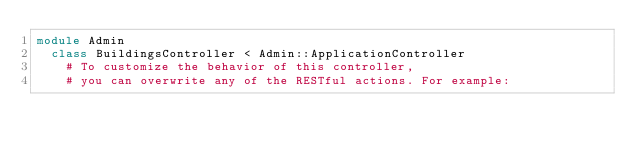<code> <loc_0><loc_0><loc_500><loc_500><_Ruby_>module Admin
  class BuildingsController < Admin::ApplicationController
    # To customize the behavior of this controller,
    # you can overwrite any of the RESTful actions. For example:</code> 